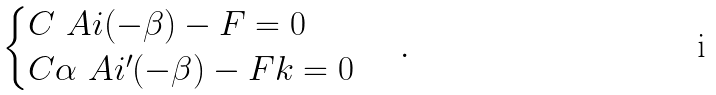Convert formula to latex. <formula><loc_0><loc_0><loc_500><loc_500>\begin{cases} C \ A i ( - \beta ) - F = 0 \\ C \alpha \ A i ^ { \prime } ( - \beta ) - F k = 0 \end{cases} \, .</formula> 